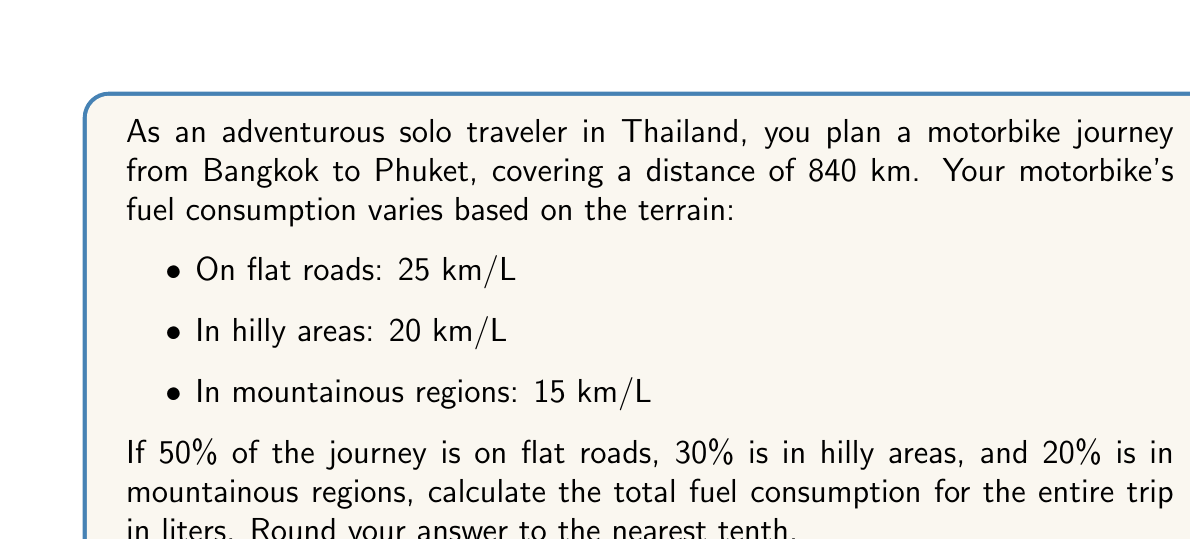Teach me how to tackle this problem. Let's break this problem down step-by-step:

1. Calculate the distance for each terrain type:
   - Flat roads: $0.50 \times 840 = 420$ km
   - Hilly areas: $0.30 \times 840 = 252$ km
   - Mountainous regions: $0.20 \times 840 = 168$ km

2. Calculate fuel consumption for each terrain type:
   - Flat roads: $\frac{420 \text{ km}}{25 \text{ km/L}} = 16.8$ L
   - Hilly areas: $\frac{252 \text{ km}}{20 \text{ km/L}} = 12.6$ L
   - Mountainous regions: $\frac{168 \text{ km}}{15 \text{ km/L}} = 11.2$ L

3. Sum up the total fuel consumption:
   $$\text{Total fuel} = 16.8 + 12.6 + 11.2 = 40.6 \text{ L}$$

4. Round to the nearest tenth:
   $40.6$ L rounds to $40.6$ L

Therefore, the total fuel consumption for the entire trip is 40.6 liters.
Answer: 40.6 L 